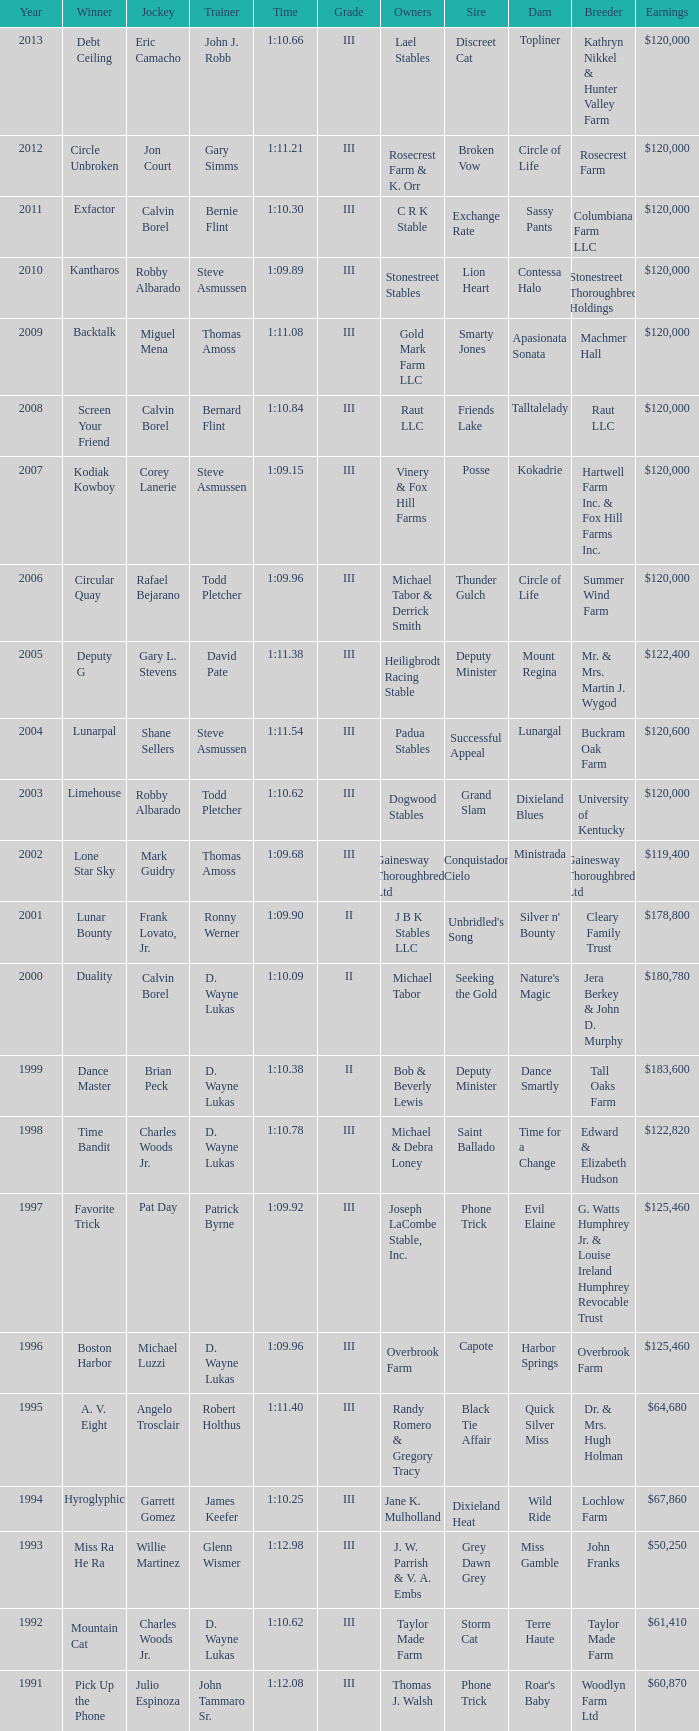Who won under Gary Simms? Circle Unbroken. 